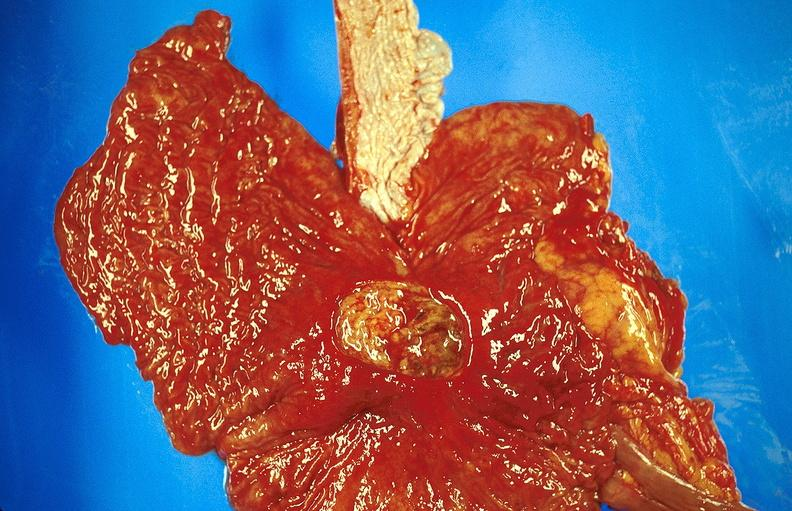s gastrointestinal present?
Answer the question using a single word or phrase. Yes 